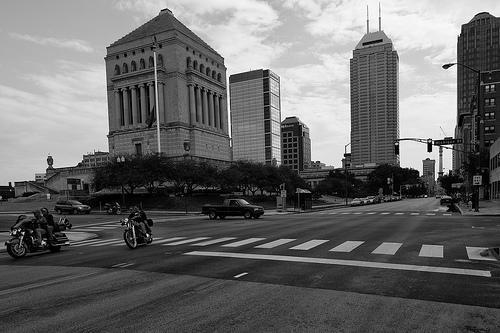How many stop lights?
Give a very brief answer. 2. 